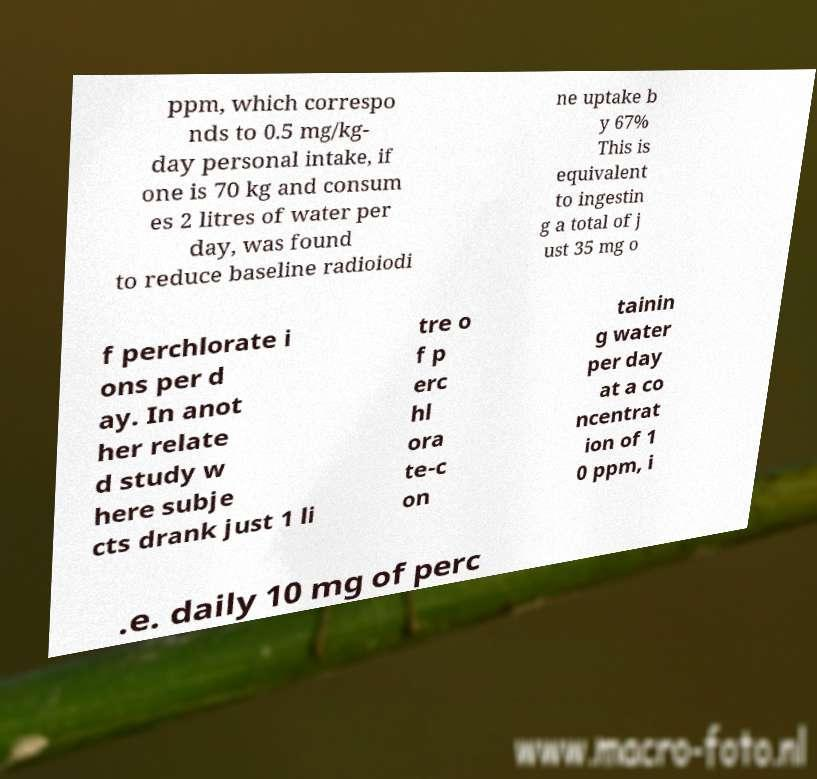What messages or text are displayed in this image? I need them in a readable, typed format. ppm, which correspo nds to 0.5 mg/kg- day personal intake, if one is 70 kg and consum es 2 litres of water per day, was found to reduce baseline radioiodi ne uptake b y 67% This is equivalent to ingestin g a total of j ust 35 mg o f perchlorate i ons per d ay. In anot her relate d study w here subje cts drank just 1 li tre o f p erc hl ora te-c on tainin g water per day at a co ncentrat ion of 1 0 ppm, i .e. daily 10 mg of perc 